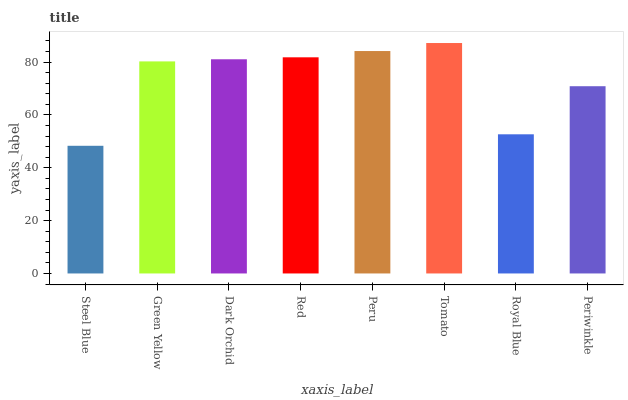Is Steel Blue the minimum?
Answer yes or no. Yes. Is Tomato the maximum?
Answer yes or no. Yes. Is Green Yellow the minimum?
Answer yes or no. No. Is Green Yellow the maximum?
Answer yes or no. No. Is Green Yellow greater than Steel Blue?
Answer yes or no. Yes. Is Steel Blue less than Green Yellow?
Answer yes or no. Yes. Is Steel Blue greater than Green Yellow?
Answer yes or no. No. Is Green Yellow less than Steel Blue?
Answer yes or no. No. Is Dark Orchid the high median?
Answer yes or no. Yes. Is Green Yellow the low median?
Answer yes or no. Yes. Is Steel Blue the high median?
Answer yes or no. No. Is Red the low median?
Answer yes or no. No. 